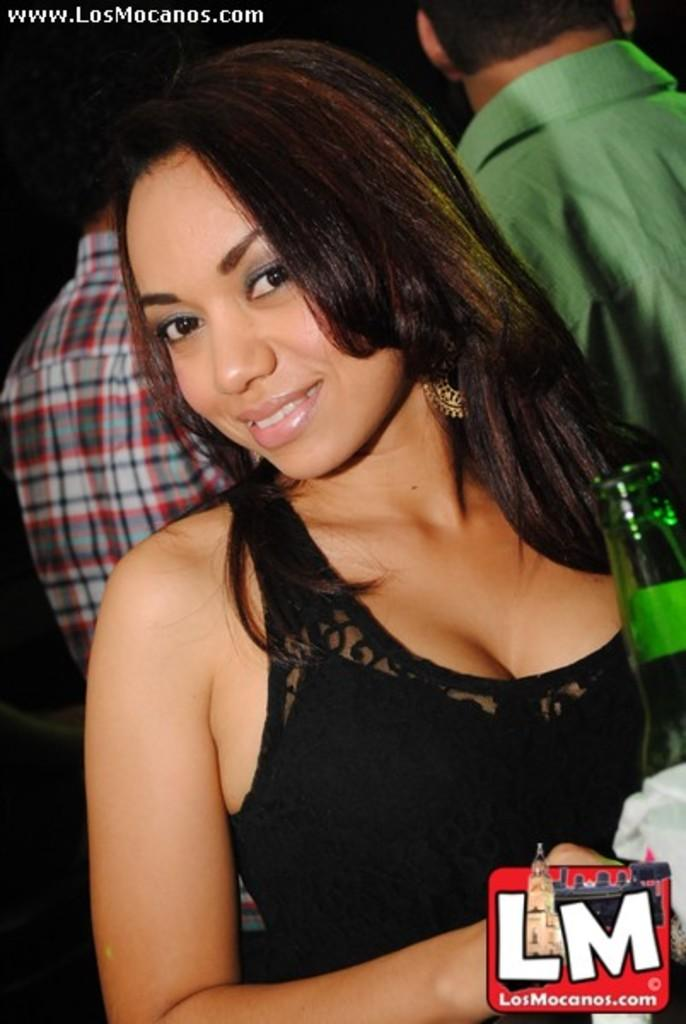Who is present in the image? There is a woman in the image. What is the woman doing in the image? The woman is smiling in the image. What is the woman wearing in the image? The woman is wearing a black dress in the image. What object is in front of the woman in the image? There is a bottle in front of the woman in the image. Can you describe the people in the background of the image? There are two men standing in the background of the image. What type of jeans is the woman wearing in the image? The woman is not wearing jeans in the image; she is wearing a black dress. Can you see any wounds on the woman in the image? There are no wounds visible on the woman in the image. 